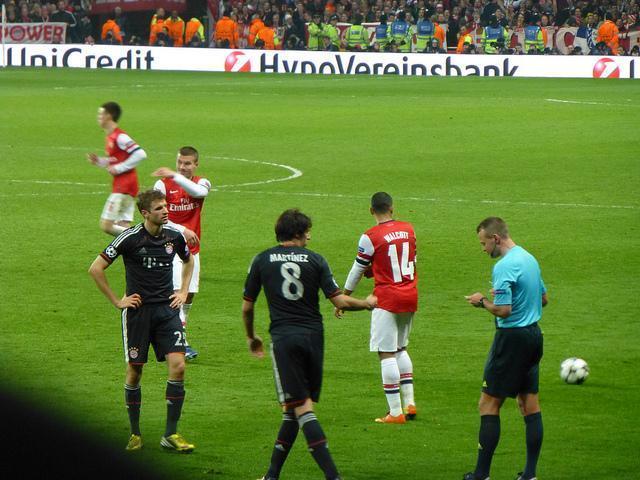How many people are there?
Give a very brief answer. 6. How many cars in the left lane?
Give a very brief answer. 0. 